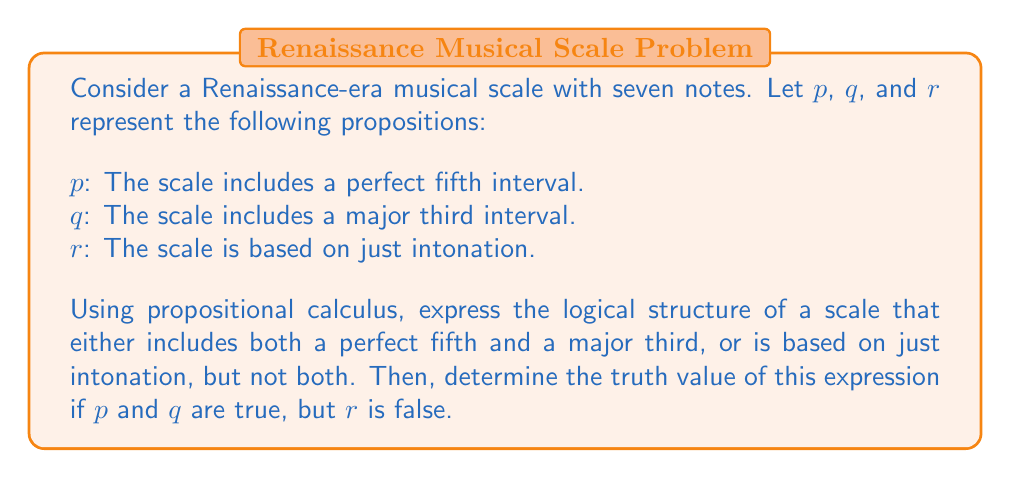Show me your answer to this math problem. To solve this problem, we'll follow these steps:

1. Express the logical structure using propositional calculus:
   The given condition can be represented as an exclusive OR (XOR) operation between two parts:
   - Part 1: The scale includes both a perfect fifth and a major third $(p \land q)$
   - Part 2: The scale is based on just intonation $(r)$

   We can express this using the following formula:
   $$ ((p \land q) \oplus r) $$
   
   Where $\oplus$ represents the XOR operation.

2. Expand the XOR operation:
   The XOR operation can be expressed as:
   $$ (A \oplus B) \equiv ((A \lor B) \land \lnot(A \land B)) $$

   Applying this to our formula:
   $$ ((p \land q) \oplus r) \equiv (((p \land q) \lor r) \land \lnot((p \land q) \land r)) $$

3. Evaluate the truth value:
   Given: $p$ is true, $q$ is true, and $r$ is false

   Let's evaluate each part:
   - $(p \land q)$ is true (both $p$ and $q$ are true)
   - $((p \land q) \lor r)$ is true (left side is true, regardless of $r$)
   - $\lnot((p \land q) \land r)$ is true (right side is false, so negation is true)

   Therefore, $((p \land q) \lor r) \land \lnot((p \land q) \land r)$ is true.

This logical structure accurately represents a Renaissance-era scale that includes both a perfect fifth and a major third but is not based on just intonation, which aligns with many temperaments developed during that period to accommodate more complex harmonies.
Answer: The logical expression $((p \land q) \oplus r)$ is true when $p$ and $q$ are true, and $r$ is false. 